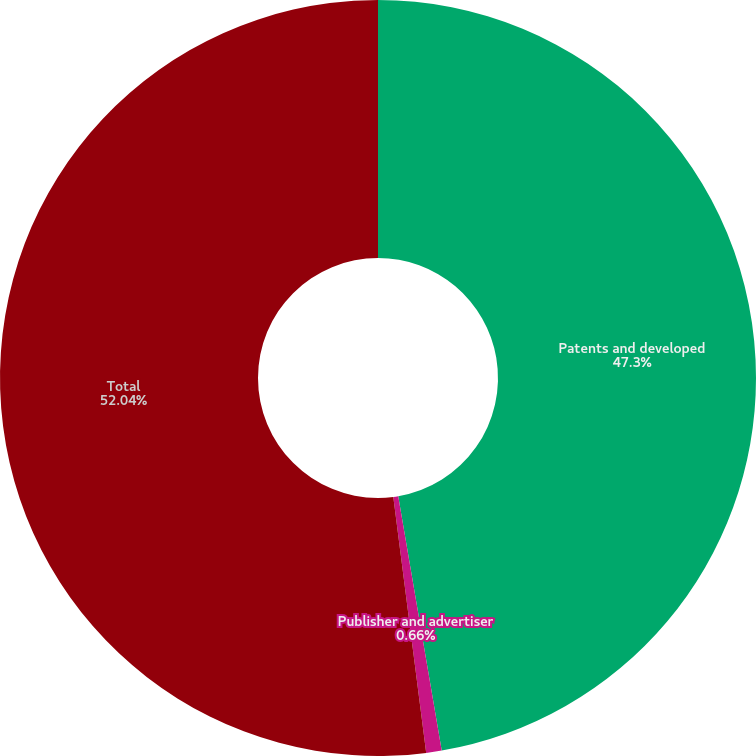Convert chart to OTSL. <chart><loc_0><loc_0><loc_500><loc_500><pie_chart><fcel>Patents and developed<fcel>Publisher and advertiser<fcel>Total<nl><fcel>47.3%<fcel>0.66%<fcel>52.03%<nl></chart> 